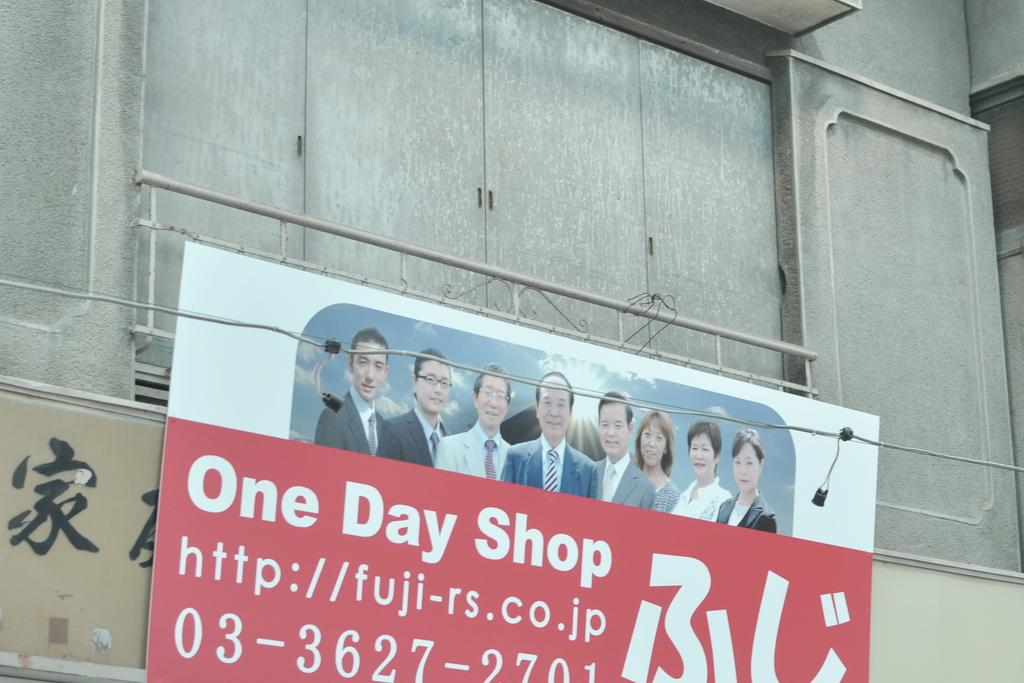<image>
Render a clear and concise summary of the photo. Sign hanging on a wall that says "One Day Shop". 